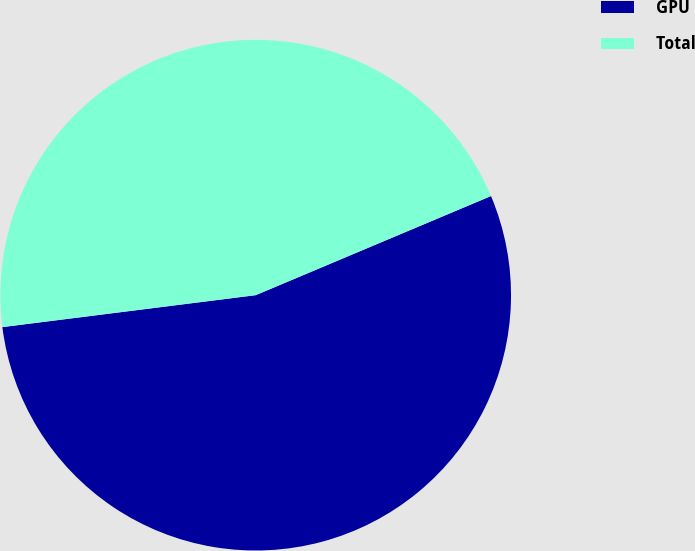Convert chart to OTSL. <chart><loc_0><loc_0><loc_500><loc_500><pie_chart><fcel>GPU<fcel>Total<nl><fcel>54.35%<fcel>45.65%<nl></chart> 